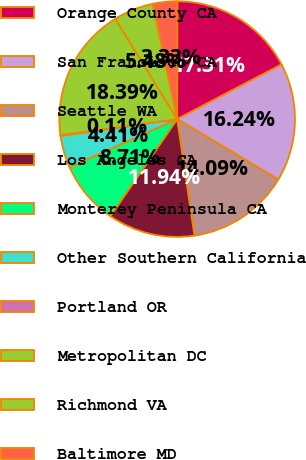Convert chart to OTSL. <chart><loc_0><loc_0><loc_500><loc_500><pie_chart><fcel>Orange County CA<fcel>San Francisco CA<fcel>Seattle WA<fcel>Los Angeles CA<fcel>Monterey Peninsula CA<fcel>Other Southern California<fcel>Portland OR<fcel>Metropolitan DC<fcel>Richmond VA<fcel>Baltimore MD<nl><fcel>17.31%<fcel>16.24%<fcel>14.09%<fcel>11.94%<fcel>8.71%<fcel>4.41%<fcel>0.11%<fcel>18.39%<fcel>5.48%<fcel>3.33%<nl></chart> 